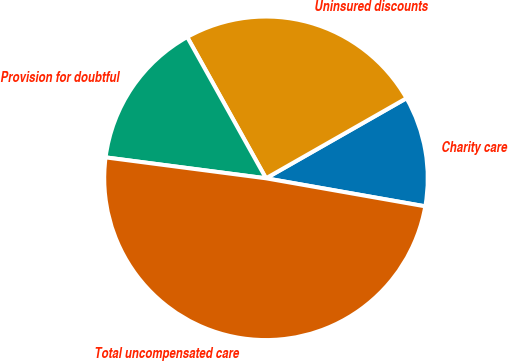Convert chart to OTSL. <chart><loc_0><loc_0><loc_500><loc_500><pie_chart><fcel>Charity care<fcel>Uninsured discounts<fcel>Provision for doubtful<fcel>Total uncompensated care<nl><fcel>11.02%<fcel>24.85%<fcel>14.84%<fcel>49.29%<nl></chart> 